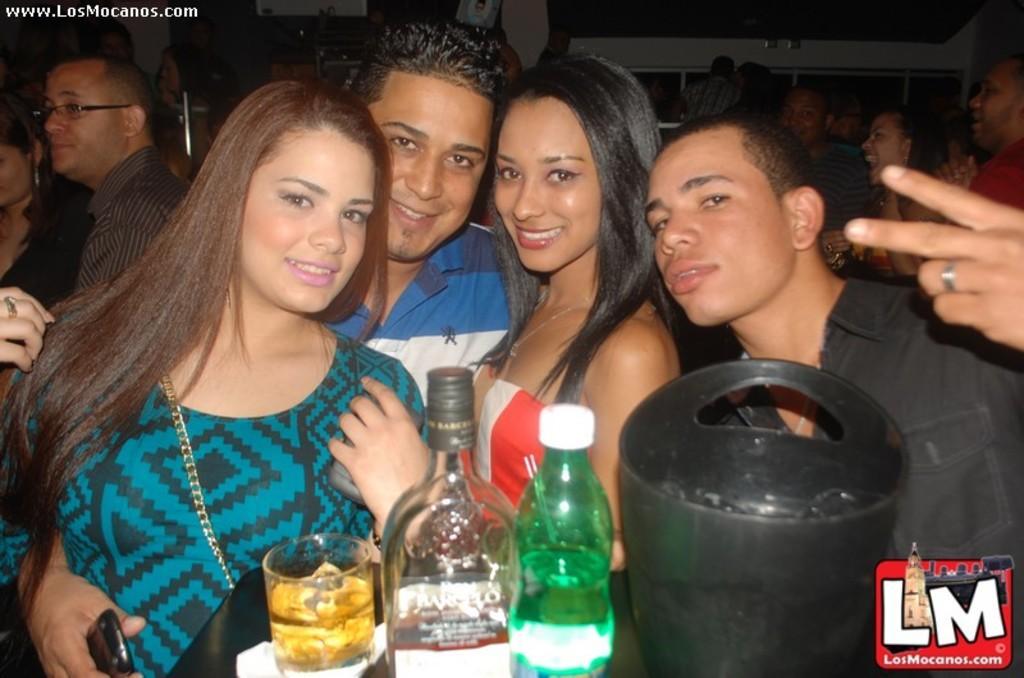In one or two sentences, can you explain what this image depicts? This image is taken indoors. In the background there is a wall and a few people are standing. In the middle of the image two women and two men are standing and they are with smiling faces. A woman is holding a mobile phone in her hand. At the bottom of the image there is a table with a glass of wine, two bottles and a bucket with ice cubes on it. 